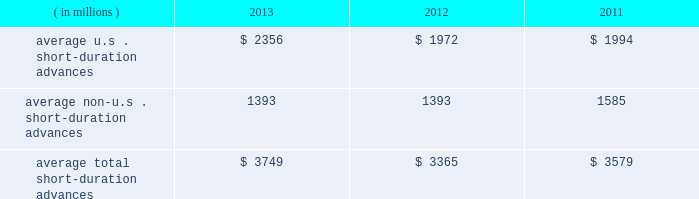Management 2019s discussion and analysis of financial condition and results of operations ( continued ) the table presents average u.s .
And non-u.s .
Short-duration advances for the years ended december 31 : years ended december 31 .
Although average short-duration advances for the year ended december 31 , 2013 increased compared to the year ended december 31 , 2012 , such average advances remained low relative to historical levels , mainly the result of clients continuing to hold higher levels of liquidity .
Average other interest-earning assets increased to $ 11.16 billion for the year ended december 31 , 2013 from $ 7.38 billion for the year ended december 31 , 2012 .
The increased levels were primarily the result of higher levels of cash collateral provided in connection with our participation in principal securities finance transactions .
Aggregate average interest-bearing deposits increased to $ 109.25 billion for the year ended december 31 , 2013 from $ 98.39 billion for the year ended december 31 , 2012 .
This increase was mainly due to higher levels of non-u.s .
Transaction accounts associated with the growth of new and existing business in assets under custody and administration .
Future transaction account levels will be influenced by the underlying asset servicing business , as well as market conditions , including the general levels of u.s .
And non-u.s .
Interest rates .
Average other short-term borrowings declined to $ 3.79 billion for the year ended december 31 , 2013 from $ 4.68 billion for the year ended december 31 , 2012 , as higher levels of client deposits provided additional liquidity .
Average long-term debt increased to $ 8.42 billion for the year ended december 31 , 2013 from $ 7.01 billion for the year ended december 31 , 2012 .
The increase primarily reflected the issuance of $ 1.0 billion of extendible notes by state street bank in december 2012 , the issuance of $ 1.5 billion of senior and subordinated debt in may 2013 , and the issuance of $ 1.0 billion of senior debt in november 2013 .
This increase was partly offset by maturities of $ 1.75 billion of senior debt in the second quarter of 2012 .
Average other interest-bearing liabilities increased to $ 6.46 billion for the year ended december 31 , 2013 from $ 5.90 billion for the year ended december 31 , 2012 , primarily the result of higher levels of cash collateral received from clients in connection with our participation in principal securities finance transactions .
Several factors could affect future levels of our net interest revenue and margin , including the mix of client liabilities ; actions of various central banks ; changes in u.s .
And non-u.s .
Interest rates ; changes in the various yield curves around the world ; revised or proposed regulatory capital or liquidity standards , or interpretations of those standards ; the amount of discount accretion generated by the former conduit securities that remain in our investment securities portfolio ; and the yields earned on securities purchased compared to the yields earned on securities sold or matured .
Based on market conditions and other factors , we continue to reinvest the majority of the proceeds from pay- downs and maturities of investment securities in highly-rated securities , such as u.s .
Treasury and agency securities , federal agency mortgage-backed securities and u.s .
And non-u.s .
Mortgage- and asset-backed securities .
The pace at which we continue to reinvest and the types of investment securities purchased will depend on the impact of market conditions and other factors over time .
We expect these factors and the levels of global interest rates to dictate what effect our reinvestment program will have on future levels of our net interest revenue and net interest margin. .
What percent has short duration advances in the us increased between 2011 and 2013? 
Computations: ((2356 - 1994) / 1994)
Answer: 0.18154. 